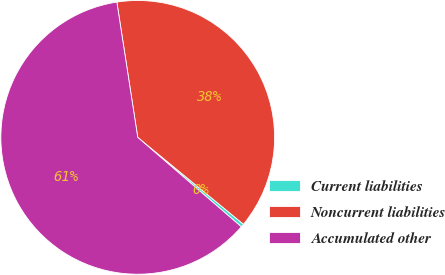Convert chart. <chart><loc_0><loc_0><loc_500><loc_500><pie_chart><fcel>Current liabilities<fcel>Noncurrent liabilities<fcel>Accumulated other<nl><fcel>0.39%<fcel>38.39%<fcel>61.23%<nl></chart> 